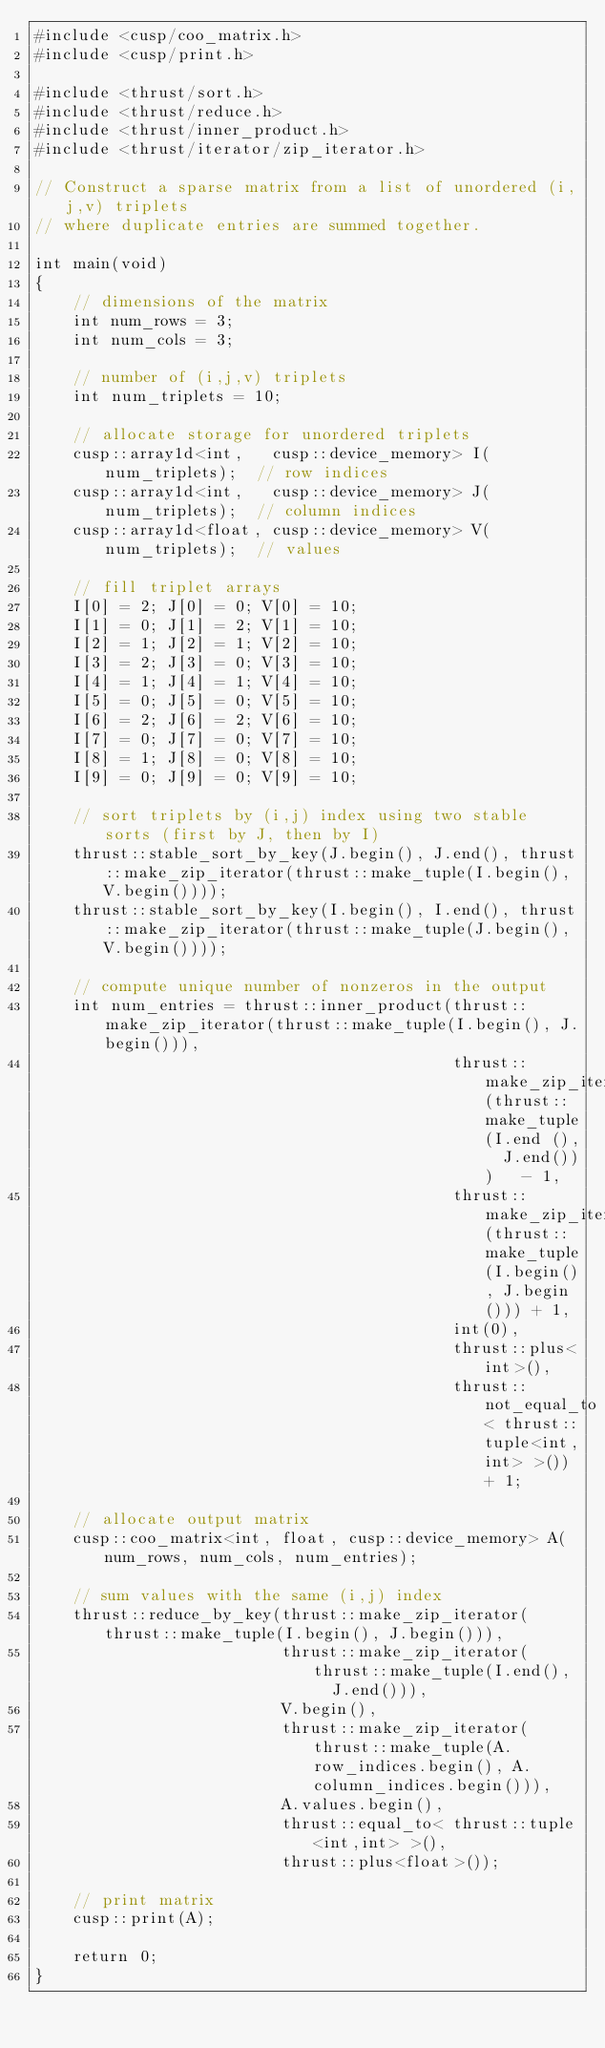Convert code to text. <code><loc_0><loc_0><loc_500><loc_500><_Cuda_>#include <cusp/coo_matrix.h>
#include <cusp/print.h>

#include <thrust/sort.h>
#include <thrust/reduce.h>
#include <thrust/inner_product.h>
#include <thrust/iterator/zip_iterator.h>

// Construct a sparse matrix from a list of unordered (i,j,v) triplets
// where duplicate entries are summed together.

int main(void)
{
    // dimensions of the matrix
    int num_rows = 3;
    int num_cols = 3;

    // number of (i,j,v) triplets
    int num_triplets = 10;

    // allocate storage for unordered triplets
    cusp::array1d<int,   cusp::device_memory> I(num_triplets);  // row indices
    cusp::array1d<int,   cusp::device_memory> J(num_triplets);  // column indices
    cusp::array1d<float, cusp::device_memory> V(num_triplets);  // values

    // fill triplet arrays
    I[0] = 2; J[0] = 0; V[0] = 10;
    I[1] = 0; J[1] = 2; V[1] = 10;
    I[2] = 1; J[2] = 1; V[2] = 10;
    I[3] = 2; J[3] = 0; V[3] = 10;
    I[4] = 1; J[4] = 1; V[4] = 10;
    I[5] = 0; J[5] = 0; V[5] = 10;
    I[6] = 2; J[6] = 2; V[6] = 10;
    I[7] = 0; J[7] = 0; V[7] = 10;
    I[8] = 1; J[8] = 0; V[8] = 10;
    I[9] = 0; J[9] = 0; V[9] = 10;

    // sort triplets by (i,j) index using two stable sorts (first by J, then by I)
    thrust::stable_sort_by_key(J.begin(), J.end(), thrust::make_zip_iterator(thrust::make_tuple(I.begin(), V.begin())));
    thrust::stable_sort_by_key(I.begin(), I.end(), thrust::make_zip_iterator(thrust::make_tuple(J.begin(), V.begin())));

    // compute unique number of nonzeros in the output
    int num_entries = thrust::inner_product(thrust::make_zip_iterator(thrust::make_tuple(I.begin(), J.begin())),
                                            thrust::make_zip_iterator(thrust::make_tuple(I.end (),  J.end()))   - 1,
                                            thrust::make_zip_iterator(thrust::make_tuple(I.begin(), J.begin())) + 1,
                                            int(0),
                                            thrust::plus<int>(),
                                            thrust::not_equal_to< thrust::tuple<int,int> >()) + 1;

    // allocate output matrix
    cusp::coo_matrix<int, float, cusp::device_memory> A(num_rows, num_cols, num_entries);
    
    // sum values with the same (i,j) index
    thrust::reduce_by_key(thrust::make_zip_iterator(thrust::make_tuple(I.begin(), J.begin())),
                          thrust::make_zip_iterator(thrust::make_tuple(I.end(),   J.end())),
                          V.begin(),
                          thrust::make_zip_iterator(thrust::make_tuple(A.row_indices.begin(), A.column_indices.begin())),
                          A.values.begin(),
                          thrust::equal_to< thrust::tuple<int,int> >(),
                          thrust::plus<float>());
    
    // print matrix
    cusp::print(A);

    return 0;
}

</code> 